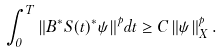<formula> <loc_0><loc_0><loc_500><loc_500>\int _ { 0 } ^ { T } { \left \| { B ^ { * } S ( t ) ^ { * } { \psi } } \right \| ^ { p } } d t \geq C \left \| { \psi } \right \| ^ { p } _ { X } .</formula> 